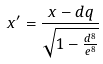<formula> <loc_0><loc_0><loc_500><loc_500>x ^ { \prime } = \frac { x - d q } { \sqrt { 1 - \frac { d ^ { 8 } } { e ^ { 8 } } } }</formula> 